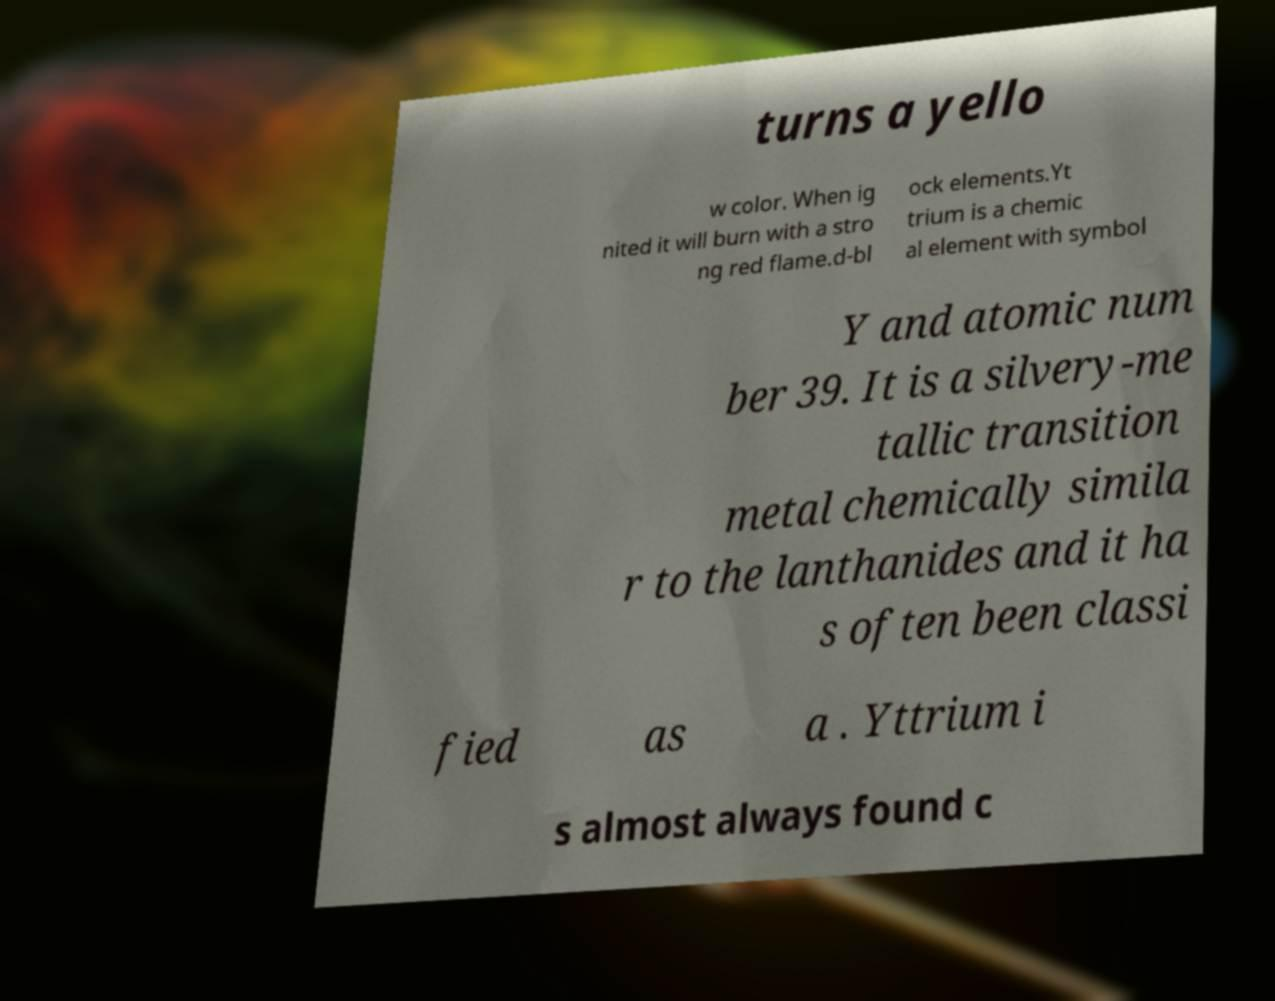Can you accurately transcribe the text from the provided image for me? turns a yello w color. When ig nited it will burn with a stro ng red flame.d-bl ock elements.Yt trium is a chemic al element with symbol Y and atomic num ber 39. It is a silvery-me tallic transition metal chemically simila r to the lanthanides and it ha s often been classi fied as a . Yttrium i s almost always found c 